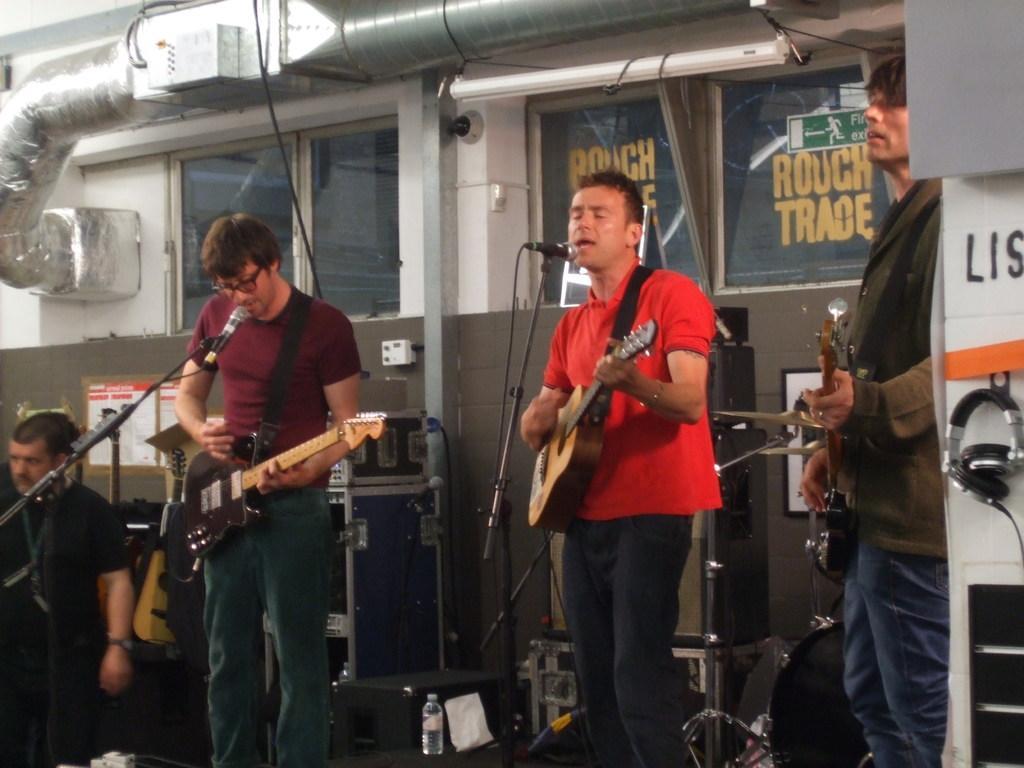Please provide a concise description of this image. These three persons are playing guitars and singing in-front of mics. On this stage there are devices, bottle, headset and speaker. A posters on wall. Far this person is standing. A picture on wall. 